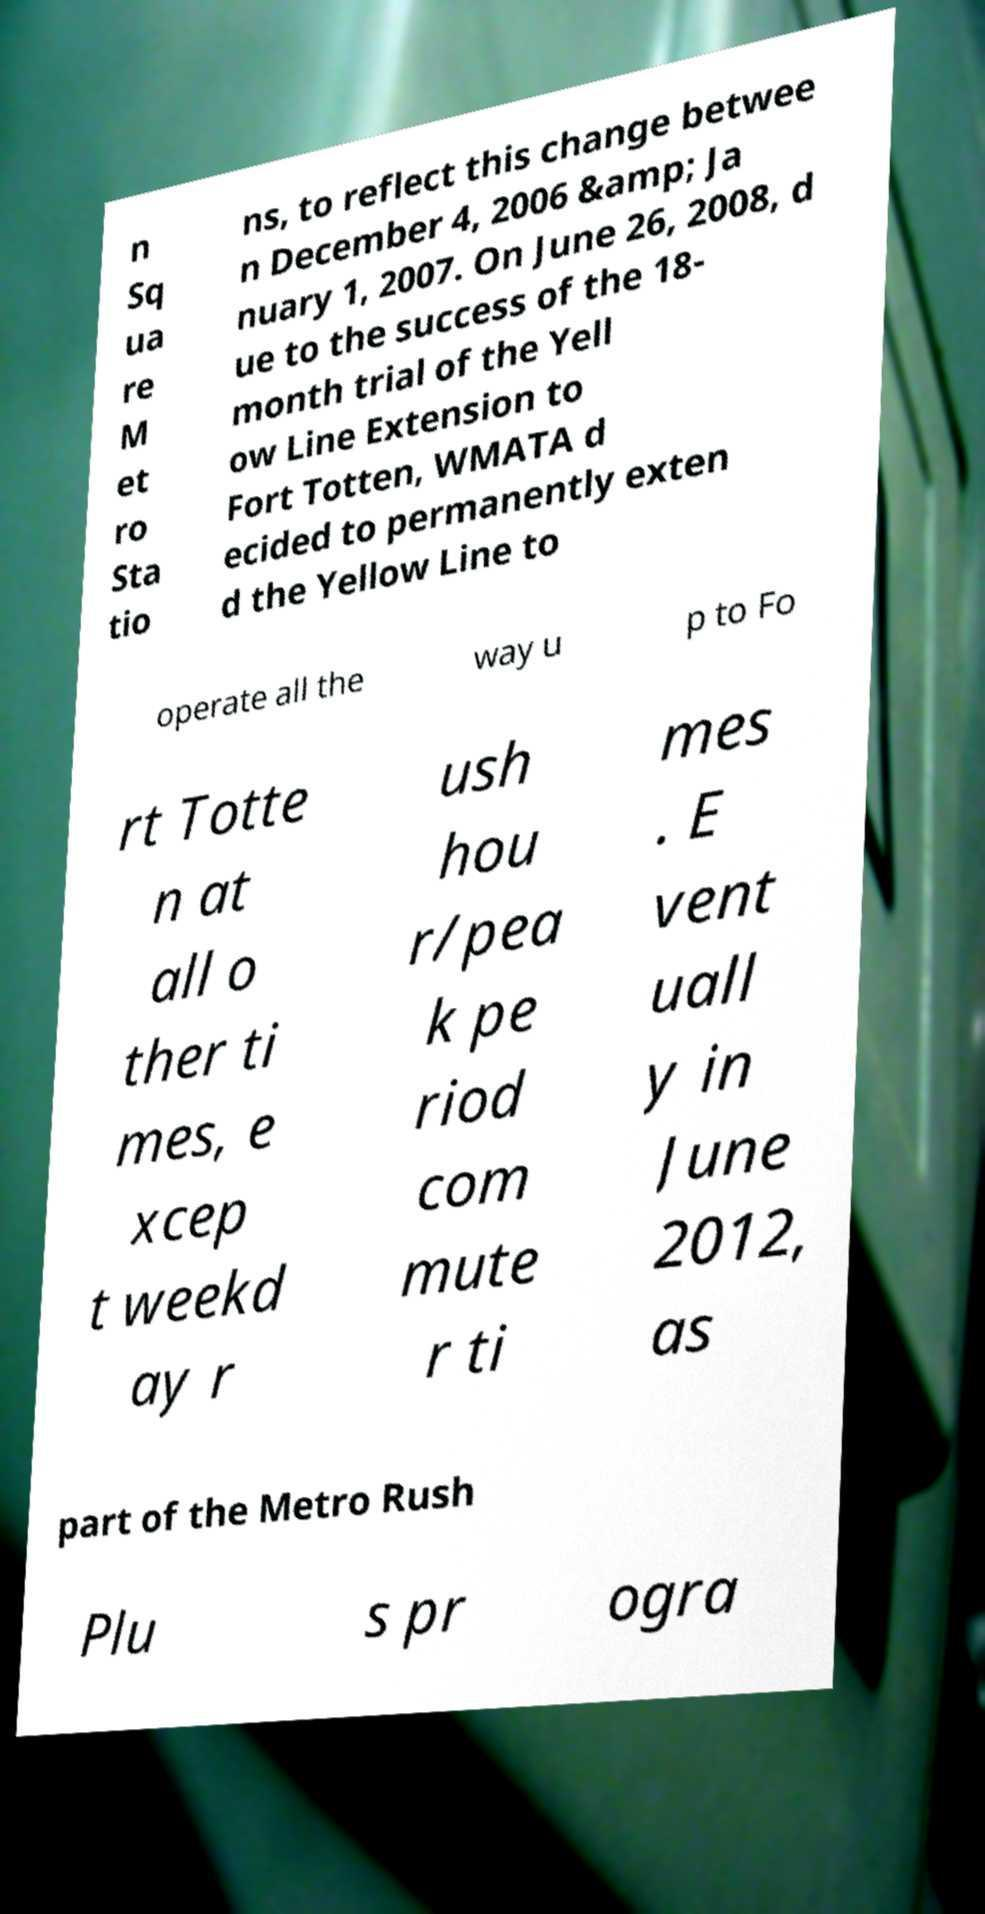Can you accurately transcribe the text from the provided image for me? n Sq ua re M et ro Sta tio ns, to reflect this change betwee n December 4, 2006 &amp; Ja nuary 1, 2007. On June 26, 2008, d ue to the success of the 18- month trial of the Yell ow Line Extension to Fort Totten, WMATA d ecided to permanently exten d the Yellow Line to operate all the way u p to Fo rt Totte n at all o ther ti mes, e xcep t weekd ay r ush hou r/pea k pe riod com mute r ti mes . E vent uall y in June 2012, as part of the Metro Rush Plu s pr ogra 